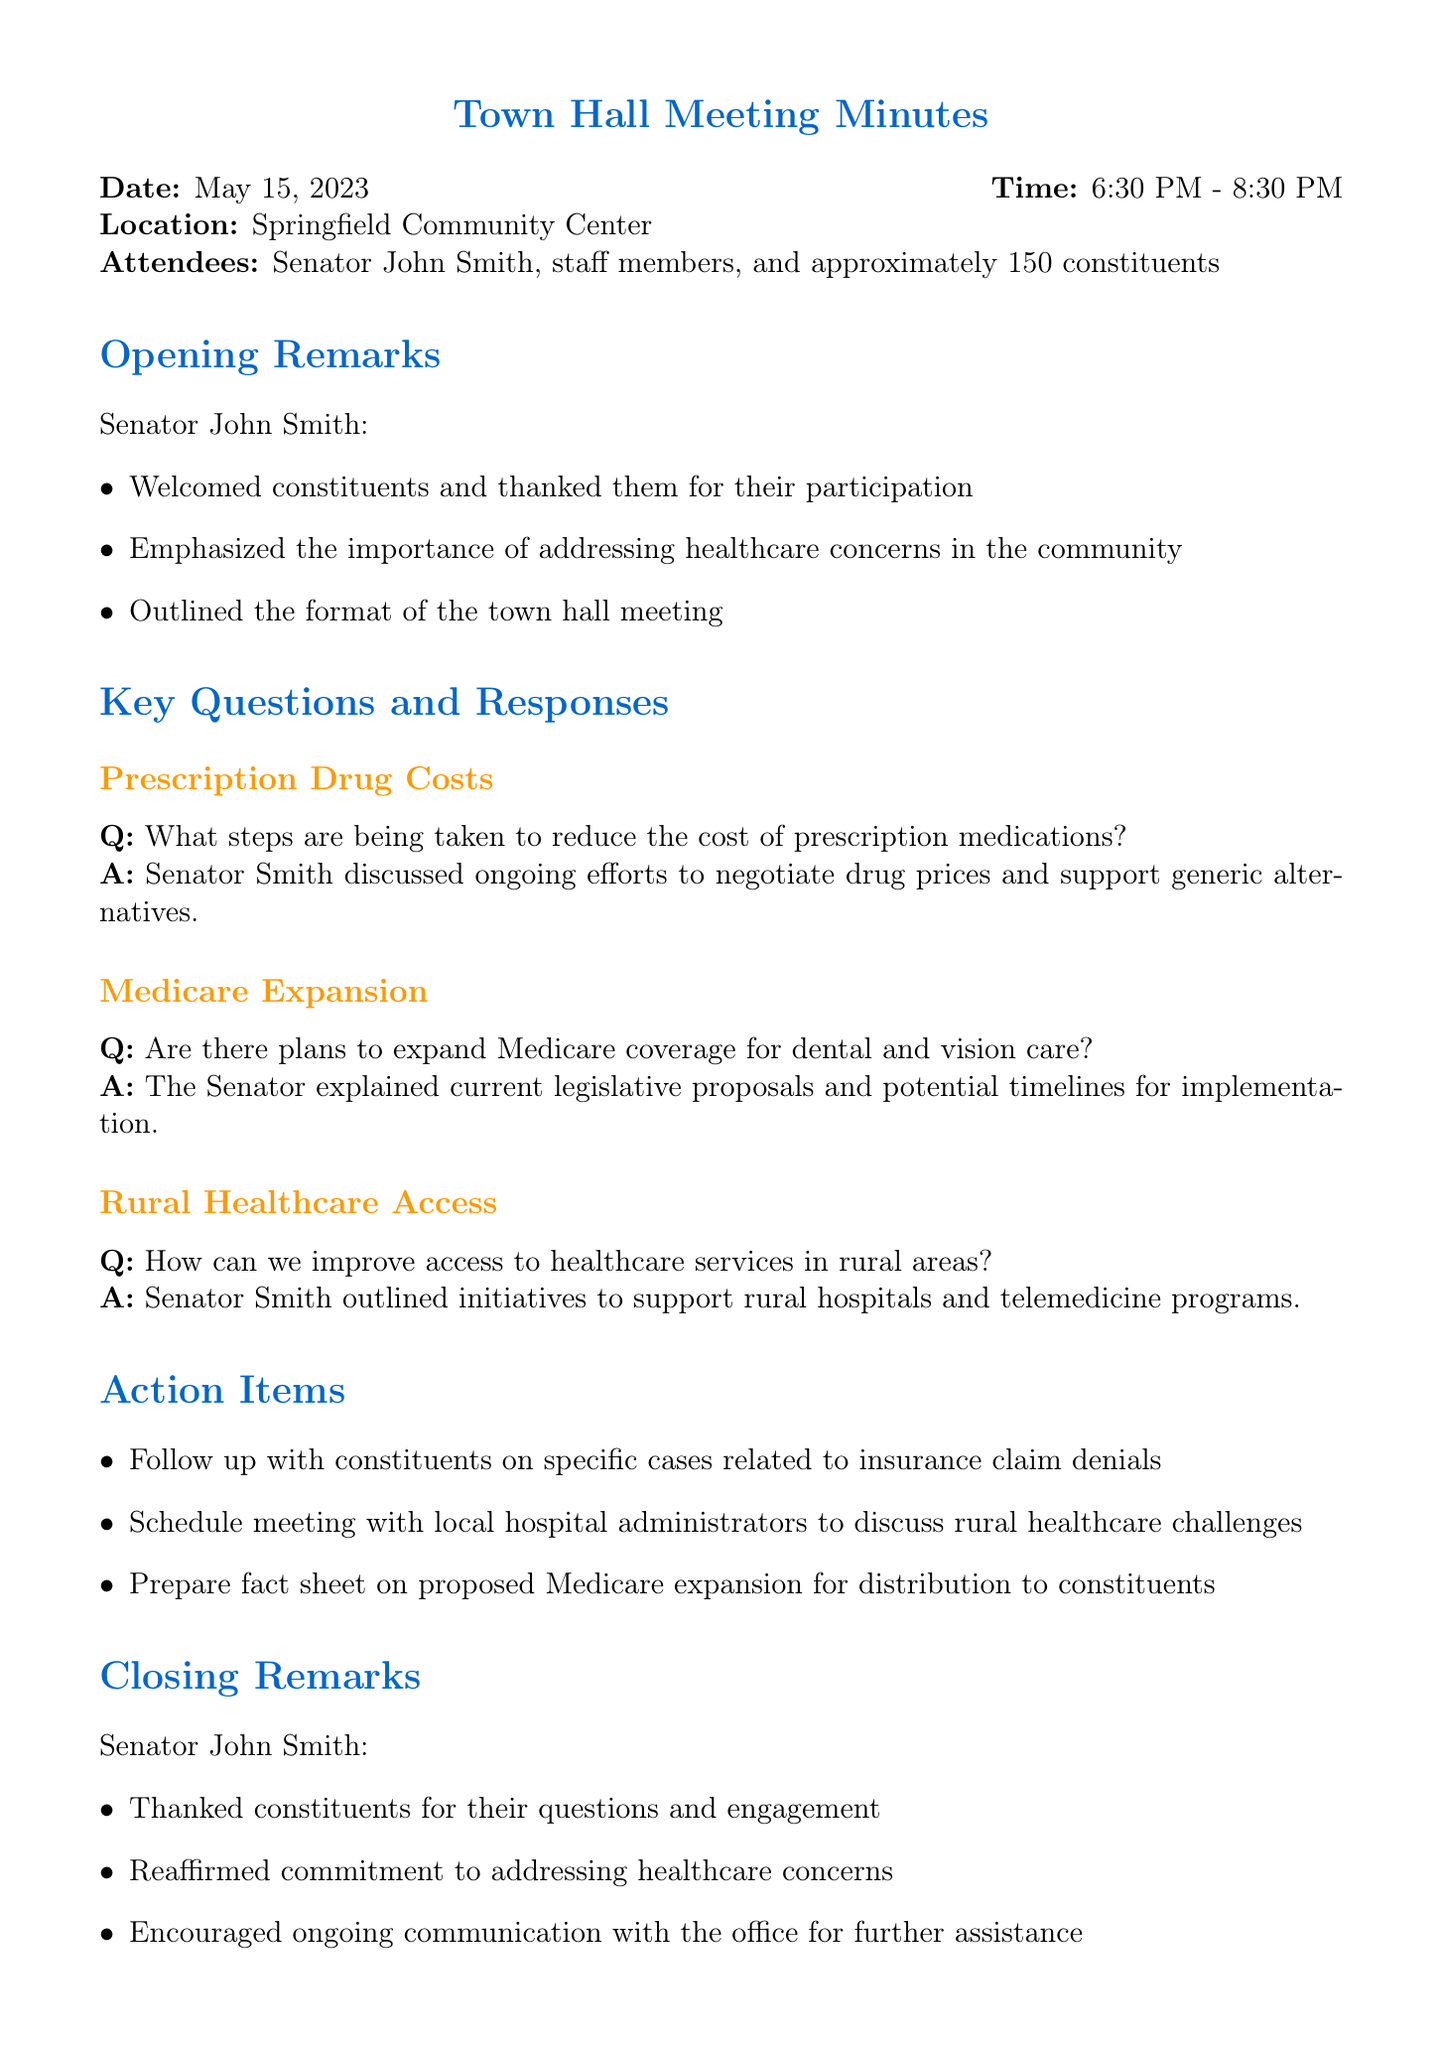What was the date of the town hall meeting? The date of the meeting is explicitly mentioned in the meeting details section of the document.
Answer: May 15, 2023 Who welcomed the constituents at the meeting? The opening remarks section specifies the speaker at the beginning of the meeting.
Answer: Senator John Smith How many constituents attended the town hall meeting? The meeting details include the approximate number of constituents present.
Answer: Approximately 150 What topic did Senator Smith discuss regarding prescription drug costs? The key questions and responses section highlights what was addressed in relation to prescription drug costs.
Answer: Ongoing efforts to negotiate drug prices and support generic alternatives What action item was mentioned to address rural healthcare challenges? The action items include a specific mention of scheduling a meeting with local entities concerning rural healthcare.
Answer: Schedule meeting with local hospital administrators to discuss rural healthcare challenges What was one of the key points mentioned in the closing remarks? The closing remarks section lists important points made by Senator Smith at the end of the meeting.
Answer: Reaffirmed commitment to addressing healthcare concerns Are there plans to expand Medicare coverage for which services? The question regarding Medicare expansion specifies the areas of coverage discussed in the meeting.
Answer: Dental and vision care What time did the meeting start? The time of the meeting is explicitly stated in the meeting details section.
Answer: 6:30 PM 